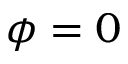<formula> <loc_0><loc_0><loc_500><loc_500>\phi = 0</formula> 